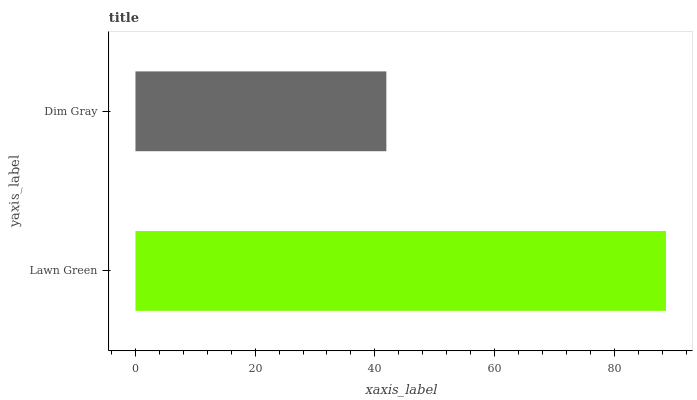Is Dim Gray the minimum?
Answer yes or no. Yes. Is Lawn Green the maximum?
Answer yes or no. Yes. Is Dim Gray the maximum?
Answer yes or no. No. Is Lawn Green greater than Dim Gray?
Answer yes or no. Yes. Is Dim Gray less than Lawn Green?
Answer yes or no. Yes. Is Dim Gray greater than Lawn Green?
Answer yes or no. No. Is Lawn Green less than Dim Gray?
Answer yes or no. No. Is Lawn Green the high median?
Answer yes or no. Yes. Is Dim Gray the low median?
Answer yes or no. Yes. Is Dim Gray the high median?
Answer yes or no. No. Is Lawn Green the low median?
Answer yes or no. No. 